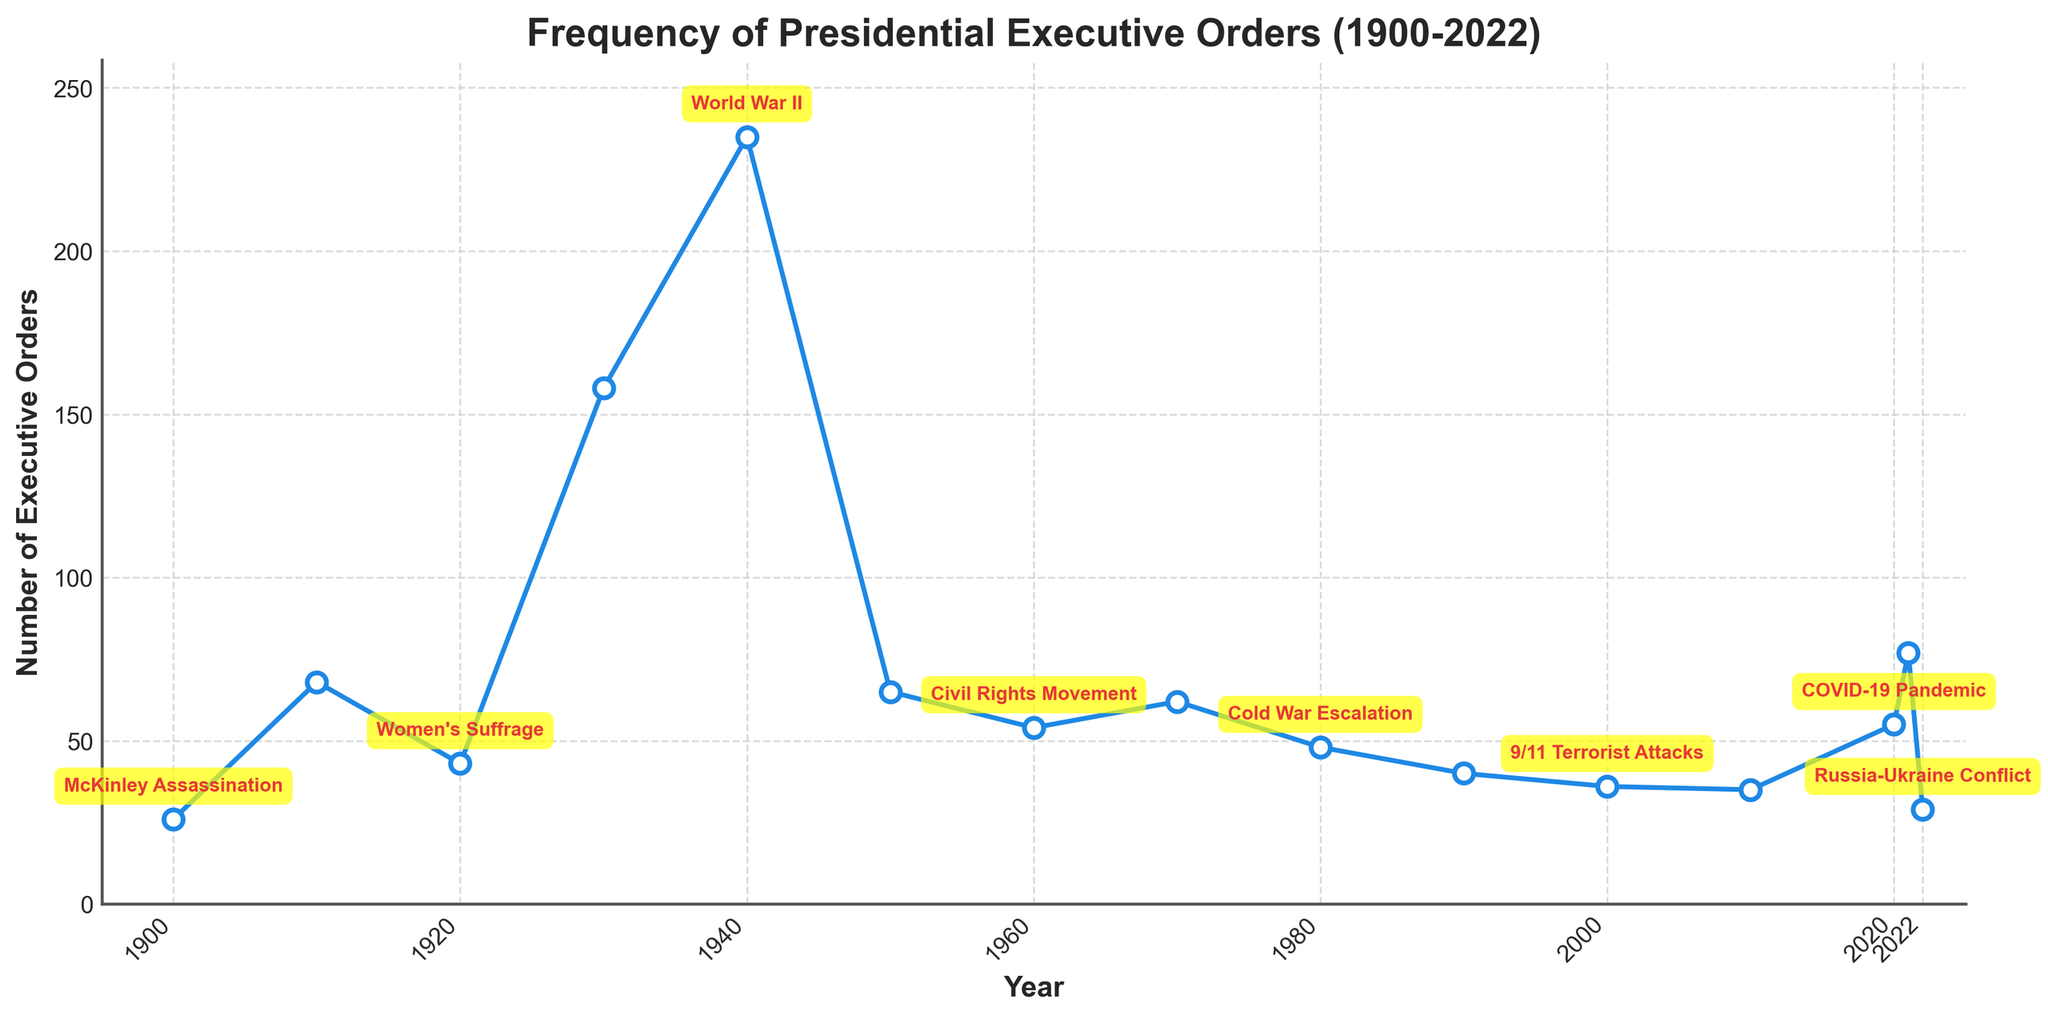What year had the highest number of executive orders issued? The peak in the line chart is the highest point, which occurs around 1940 with 235 executive orders during World War II.
Answer: 1940 Which historical event corresponds to the largest spike in executive orders around the 1930s-1940s? The largest spike in the 1930s-1940s corresponds to World War II, reflected in the high number of executive orders in 1940.
Answer: World War II How does the number of executive orders in 2021 compare to 2022? 2021 had 77 executive orders and 2022 had 29. Therefore, 2021 had significantly more executive orders than 2022.
Answer: 2021 had more What is the average number of executive orders from 2000 to 2022? The number of executive orders from 2000 to 2022 are 36, 35, 55, 77, and 29. The total is 232 and there are 5 years. So, the average is 46.4.
Answer: 46.4 How many events listed had more than 100 executive orders issued? Analyzing the graph, we see that only 1930 during the Great Depression (158) and 1940 during World War II (235) had more than 100 executive orders.
Answer: 2 Which year shows the lowest number of executive orders issued in the recent two decades? From the chart, in recent two decades (2000-2020), the lowest number of executive orders issued is 29 in 2022.
Answer: 2022 Compare the frequency of executive orders issued during the Great Depression and the Affordable Care Act. During the Great Depression (1930), there were 158 executive orders, whereas during the Affordable Care Act (2010), there were 35. Thus, significantly more orders were issued during the Great Depression.
Answer: More during Great Depression Compare the number of executive orders issued during the Women's Suffrage and the COVID-19 Pandemic. In 1920, during the Women's Suffrage, there were 43 executive orders issued. In 2020, during the COVID-19 Pandemic, there were 55 orders. Thus, more orders were issued during the COVID-19 Pandemic.
Answer: More during COVID-19 Pandemic Were there more executive orders issued during the Korean War or the Vietnam War? The chart shows 65 executive orders during the Korean War (1950) and 62 during the Vietnam War (1970). Thus, there were slightly more during the Korean War.
Answer: Korean War What was the trend in the number of executive orders between 1980 and 2000? The chart displays a decreasing trend from 48 in 1980, 40 in 1990, and 36 in 2000, indicating the number of executive orders issued declined during these two decades.
Answer: Decreasing trend 